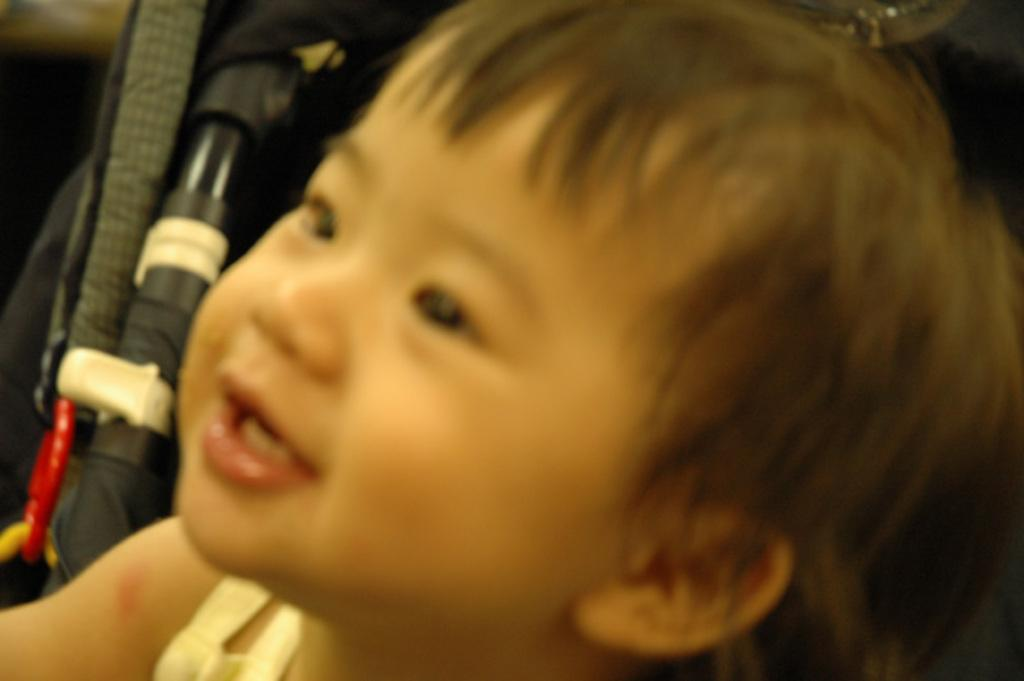Who is present in the image? There is a boy in the image. What is the boy's expression? The boy is smiling. What can be seen in the background of the image? There is a black bag and an object that is green and white in color in the background of the image. What type of potato is being used as a prop in the image? There is no potato present in the image. How does the sun appear in the image? The image does not show the sun; it only shows a boy and objects in the background. 